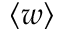<formula> <loc_0><loc_0><loc_500><loc_500>\langle w \rangle</formula> 